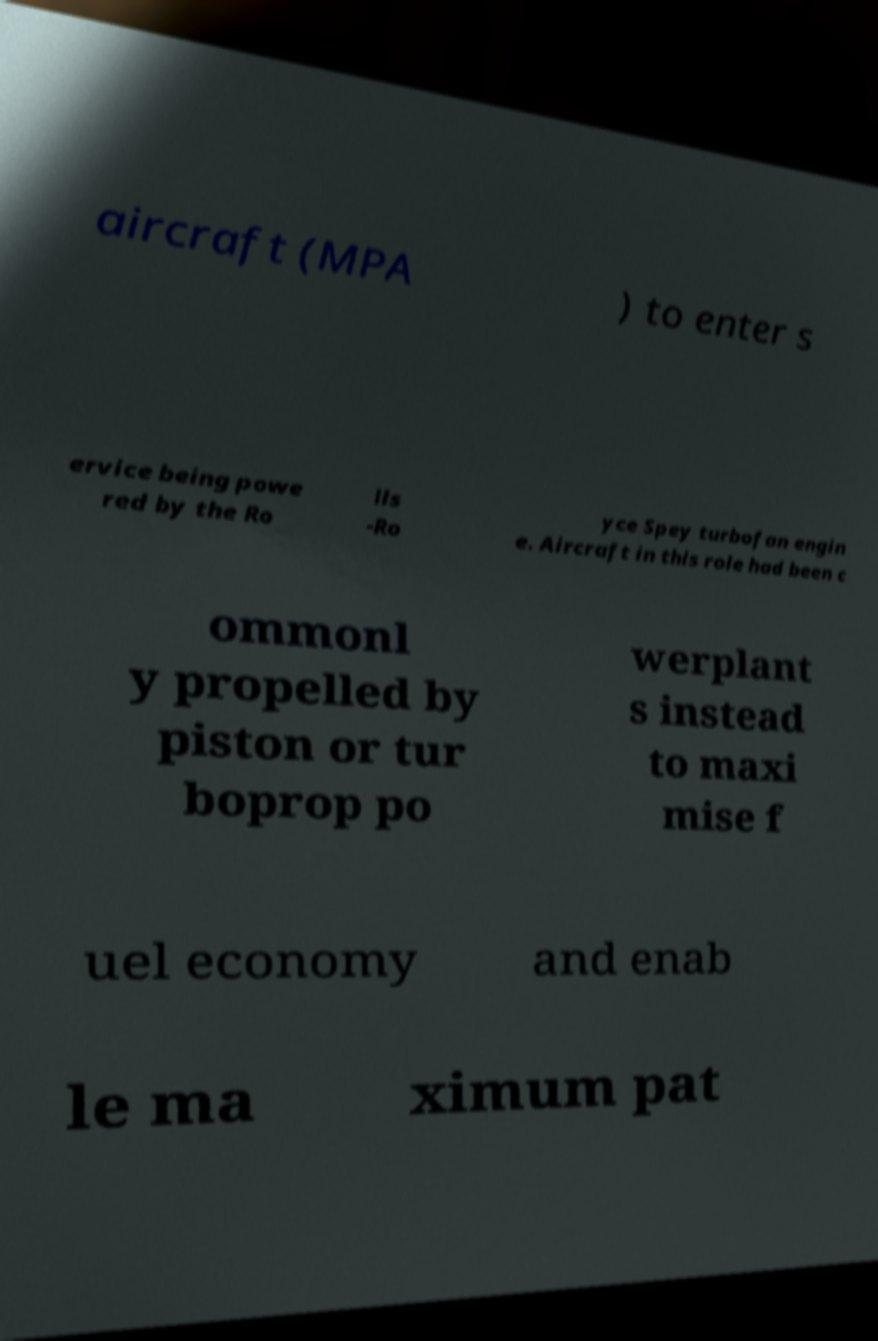For documentation purposes, I need the text within this image transcribed. Could you provide that? aircraft (MPA ) to enter s ervice being powe red by the Ro lls -Ro yce Spey turbofan engin e. Aircraft in this role had been c ommonl y propelled by piston or tur boprop po werplant s instead to maxi mise f uel economy and enab le ma ximum pat 